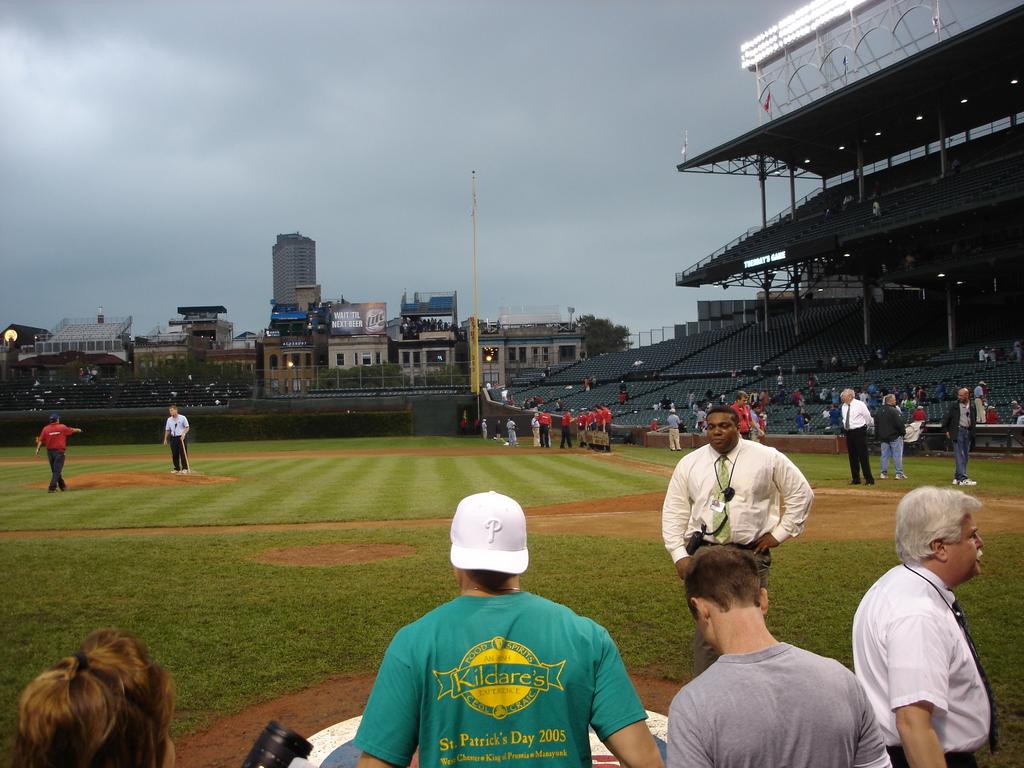What sport is being played?
Offer a very short reply. Answering does not require reading text in the image. Which st patricks day is on the man's shirt?
Offer a terse response. 2005. 